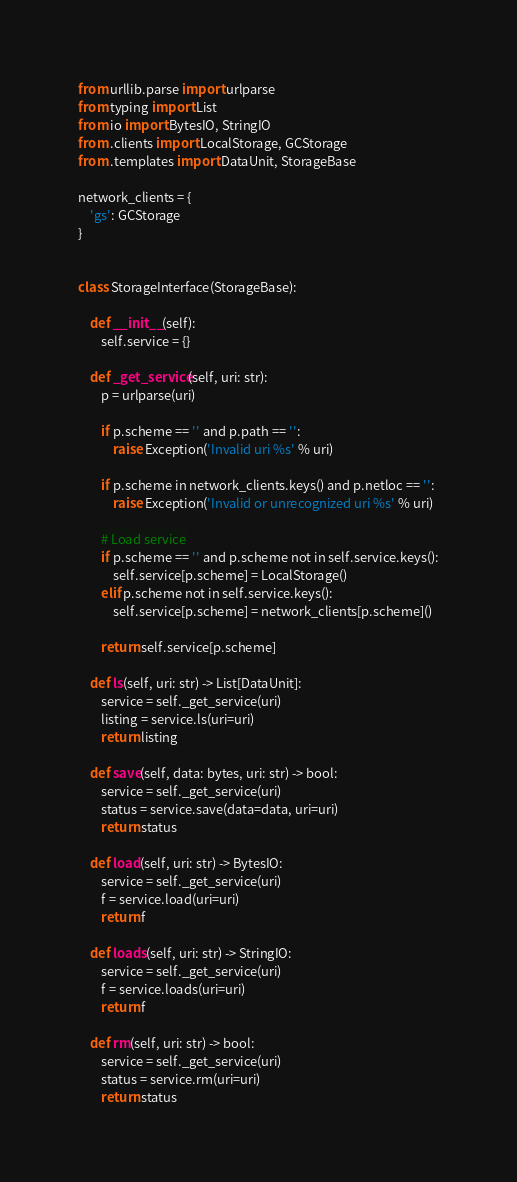Convert code to text. <code><loc_0><loc_0><loc_500><loc_500><_Python_>from urllib.parse import urlparse
from typing import List
from io import BytesIO, StringIO
from .clients import LocalStorage, GCStorage
from .templates import DataUnit, StorageBase

network_clients = {
    'gs': GCStorage
}


class StorageInterface(StorageBase):

    def __init__(self):
        self.service = {}

    def _get_service(self, uri: str):
        p = urlparse(uri)

        if p.scheme == '' and p.path == '':
            raise Exception('Invalid uri %s' % uri)

        if p.scheme in network_clients.keys() and p.netloc == '':
            raise Exception('Invalid or unrecognized uri %s' % uri)

        # Load service
        if p.scheme == '' and p.scheme not in self.service.keys():
            self.service[p.scheme] = LocalStorage()
        elif p.scheme not in self.service.keys():
            self.service[p.scheme] = network_clients[p.scheme]()

        return self.service[p.scheme]

    def ls(self, uri: str) -> List[DataUnit]:
        service = self._get_service(uri)
        listing = service.ls(uri=uri)
        return listing

    def save(self, data: bytes, uri: str) -> bool:
        service = self._get_service(uri)
        status = service.save(data=data, uri=uri)
        return status

    def load(self, uri: str) -> BytesIO:
        service = self._get_service(uri)
        f = service.load(uri=uri)
        return f

    def loads(self, uri: str) -> StringIO:
        service = self._get_service(uri)
        f = service.loads(uri=uri)
        return f

    def rm(self, uri: str) -> bool:
        service = self._get_service(uri)
        status = service.rm(uri=uri)
        return status
</code> 